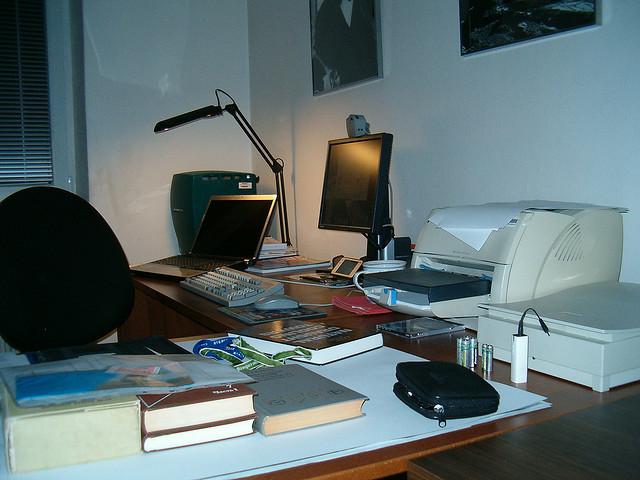How many laptops are on the lady's desk?
Short answer required. 1. Are the books hardback?
Short answer required. Yes. Is the scanner on the left or right of the monitor?
Write a very short answer. Right. What kind of business is going on at this premises?
Answer briefly. Accounting. Is this most likely a man or woman's office?
Keep it brief. Man's. Is there a functional laptop on the table?
Keep it brief. Yes. Is the monitor turned on?
Quick response, please. No. What is the desk made of?
Write a very short answer. Wood. Is this an office?
Quick response, please. Yes. Is there a photo quality printer on the desk?
Quick response, please. Yes. How many books are in the room?
Give a very brief answer. 6. 